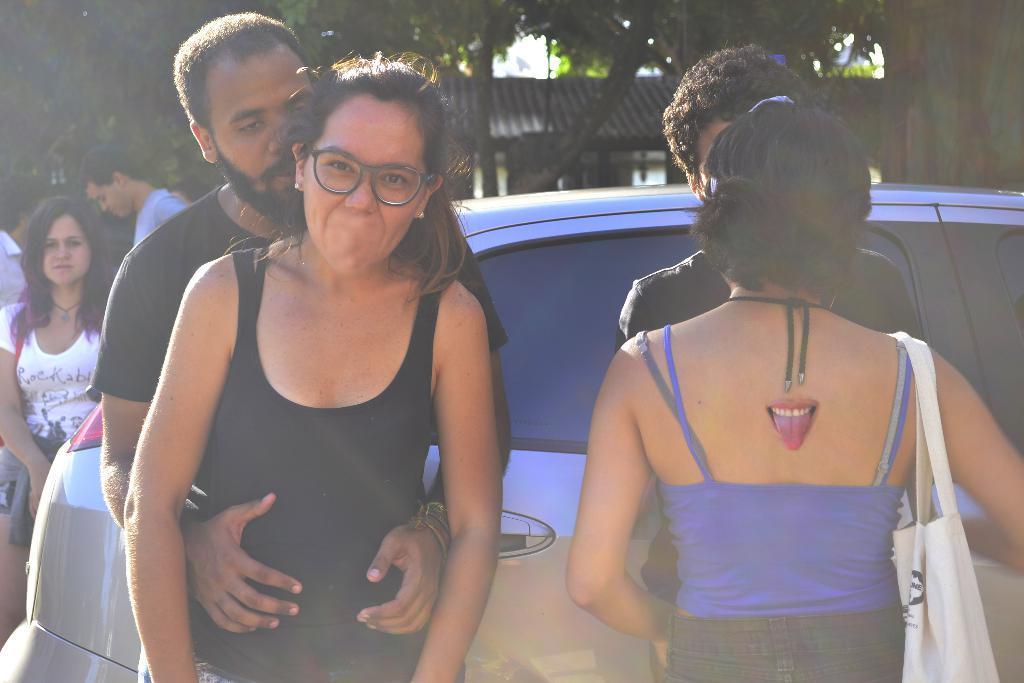Can you describe this image briefly? In this picture we can see some people are standing, on the right side there is a car, in the background we can see trees. 